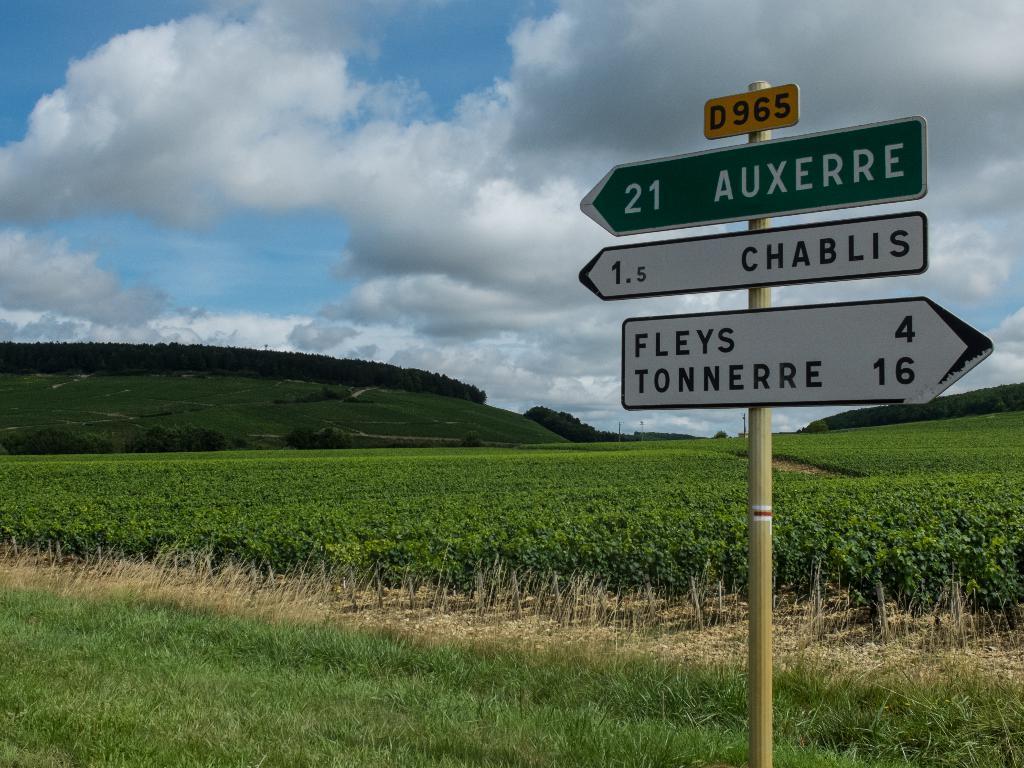In one or two sentences, can you explain what this image depicts? In this image, we can see fields, sign boards. At the bottom, there is ground covered with grass. In the background, there is mountain. At the top, there are clouds in the sky. 